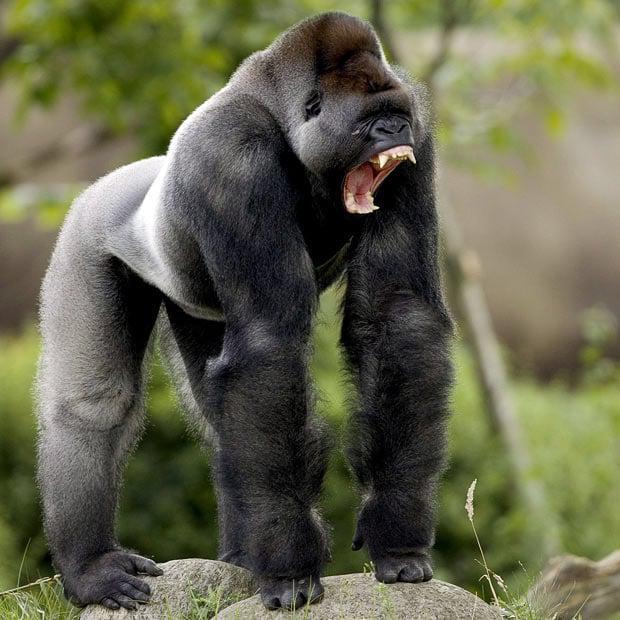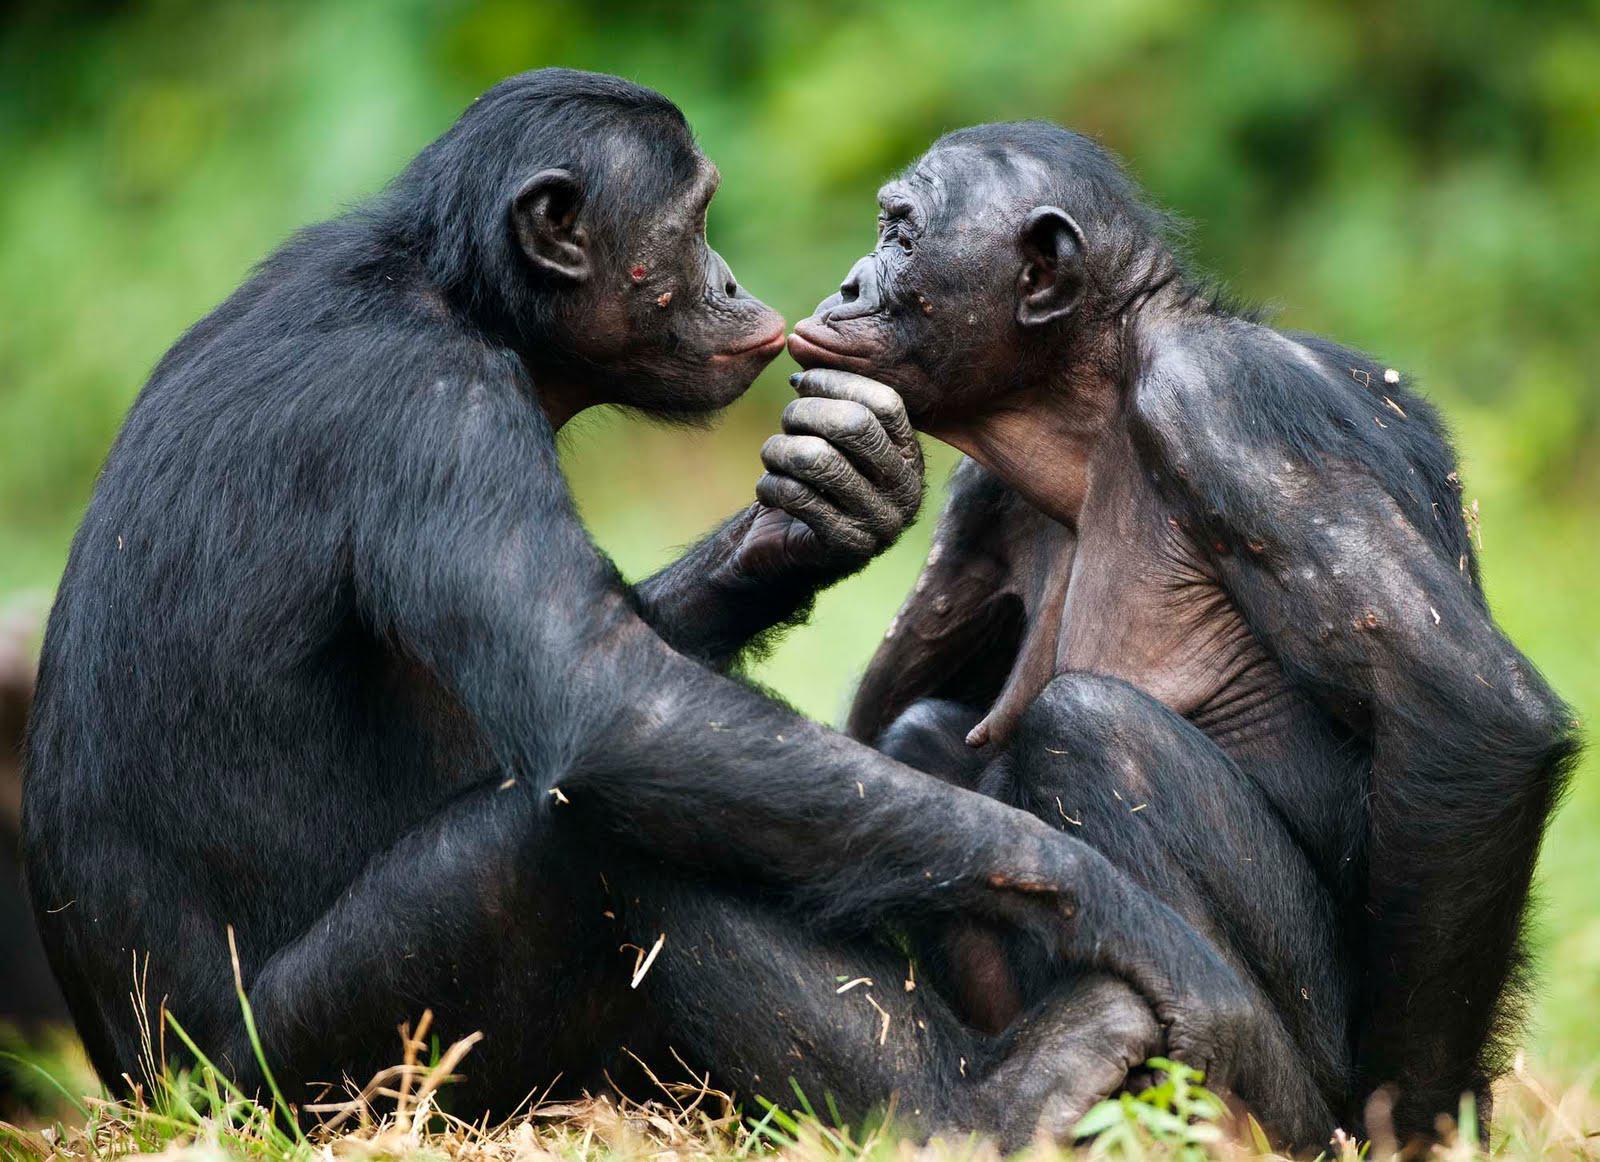The first image is the image on the left, the second image is the image on the right. Given the left and right images, does the statement "Two of the apes are posed in contact and face to face, but neither is held off the ground by the other." hold true? Answer yes or no. Yes. The first image is the image on the left, the second image is the image on the right. For the images displayed, is the sentence "A baby gorilla is with an adult gorilla in at least one of the images." factually correct? Answer yes or no. No. 